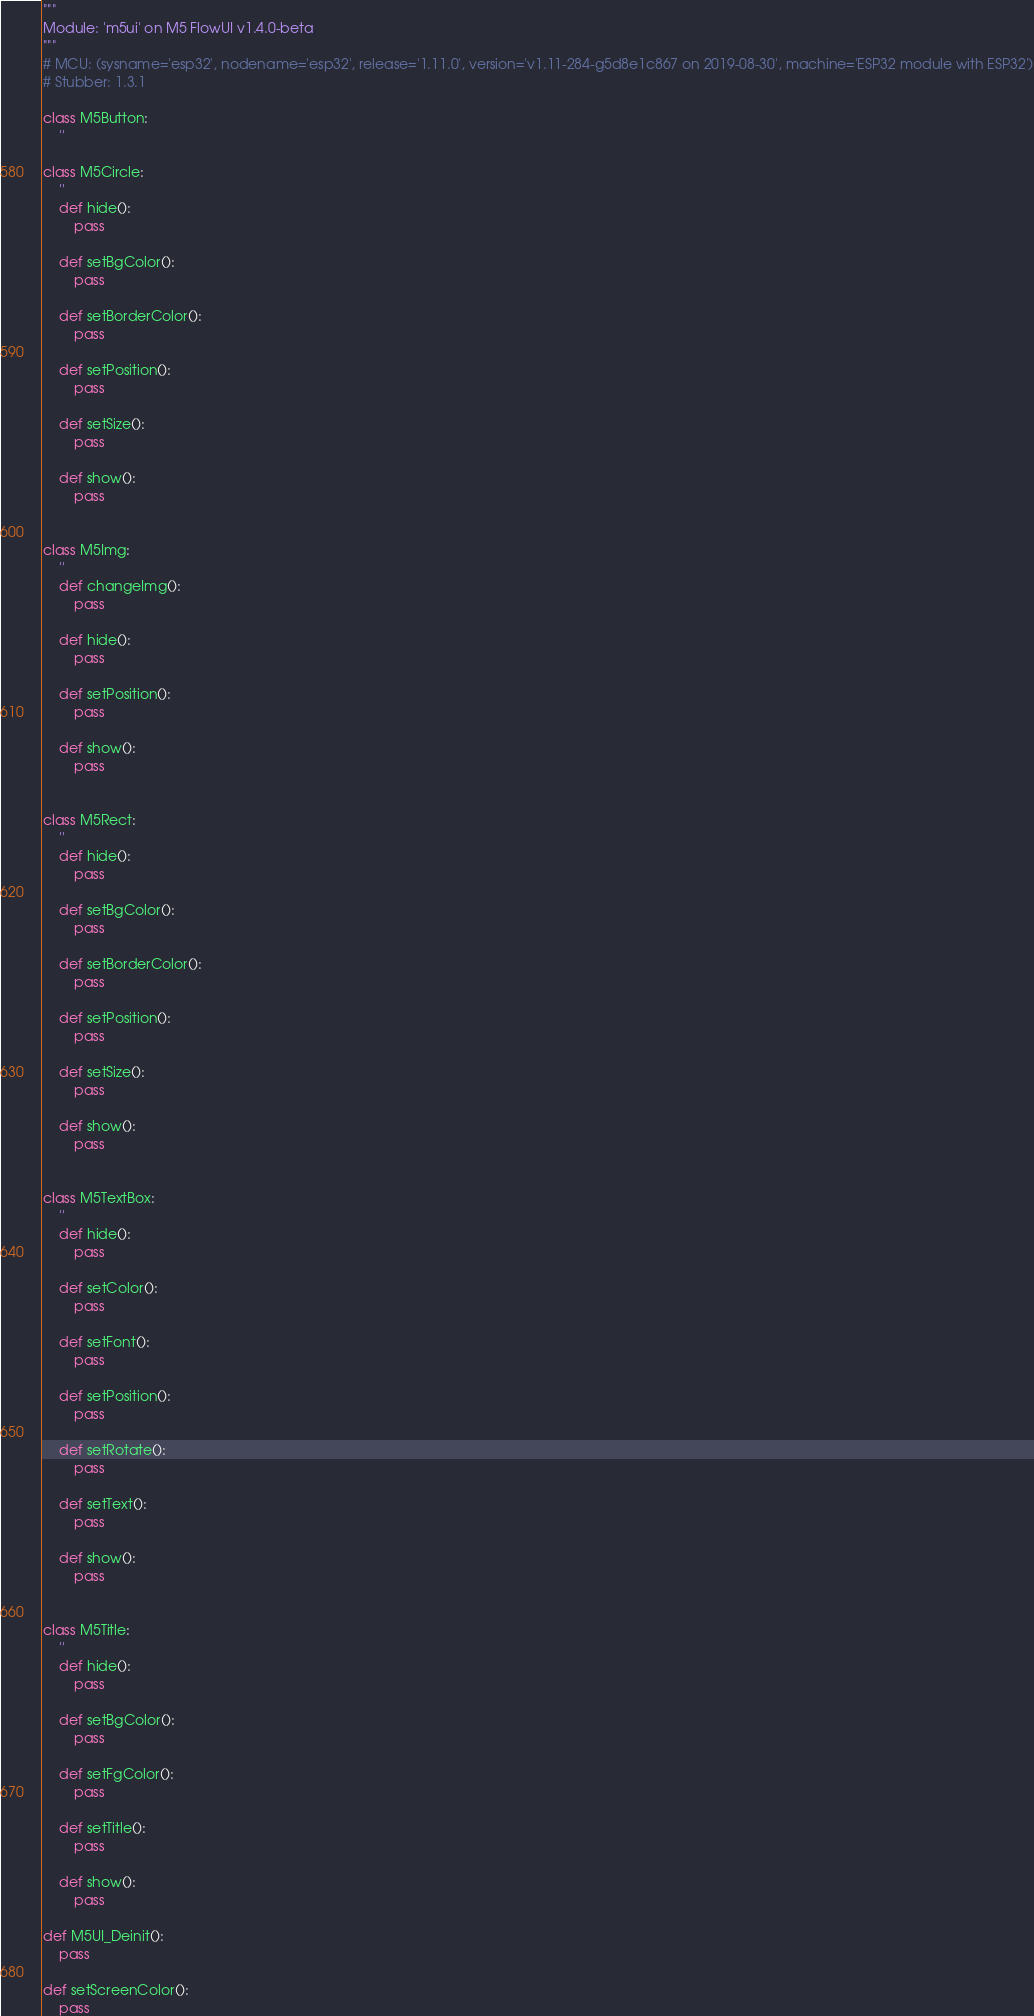Convert code to text. <code><loc_0><loc_0><loc_500><loc_500><_Python_>"""
Module: 'm5ui' on M5 FlowUI v1.4.0-beta
"""
# MCU: (sysname='esp32', nodename='esp32', release='1.11.0', version='v1.11-284-g5d8e1c867 on 2019-08-30', machine='ESP32 module with ESP32')
# Stubber: 1.3.1

class M5Button:
    ''

class M5Circle:
    ''
    def hide():
        pass

    def setBgColor():
        pass

    def setBorderColor():
        pass

    def setPosition():
        pass

    def setSize():
        pass

    def show():
        pass


class M5Img:
    ''
    def changeImg():
        pass

    def hide():
        pass

    def setPosition():
        pass

    def show():
        pass


class M5Rect:
    ''
    def hide():
        pass

    def setBgColor():
        pass

    def setBorderColor():
        pass

    def setPosition():
        pass

    def setSize():
        pass

    def show():
        pass


class M5TextBox:
    ''
    def hide():
        pass

    def setColor():
        pass

    def setFont():
        pass

    def setPosition():
        pass

    def setRotate():
        pass

    def setText():
        pass

    def show():
        pass


class M5Title:
    ''
    def hide():
        pass

    def setBgColor():
        pass

    def setFgColor():
        pass

    def setTitle():
        pass

    def show():
        pass

def M5UI_Deinit():
    pass

def setScreenColor():
    pass

</code> 